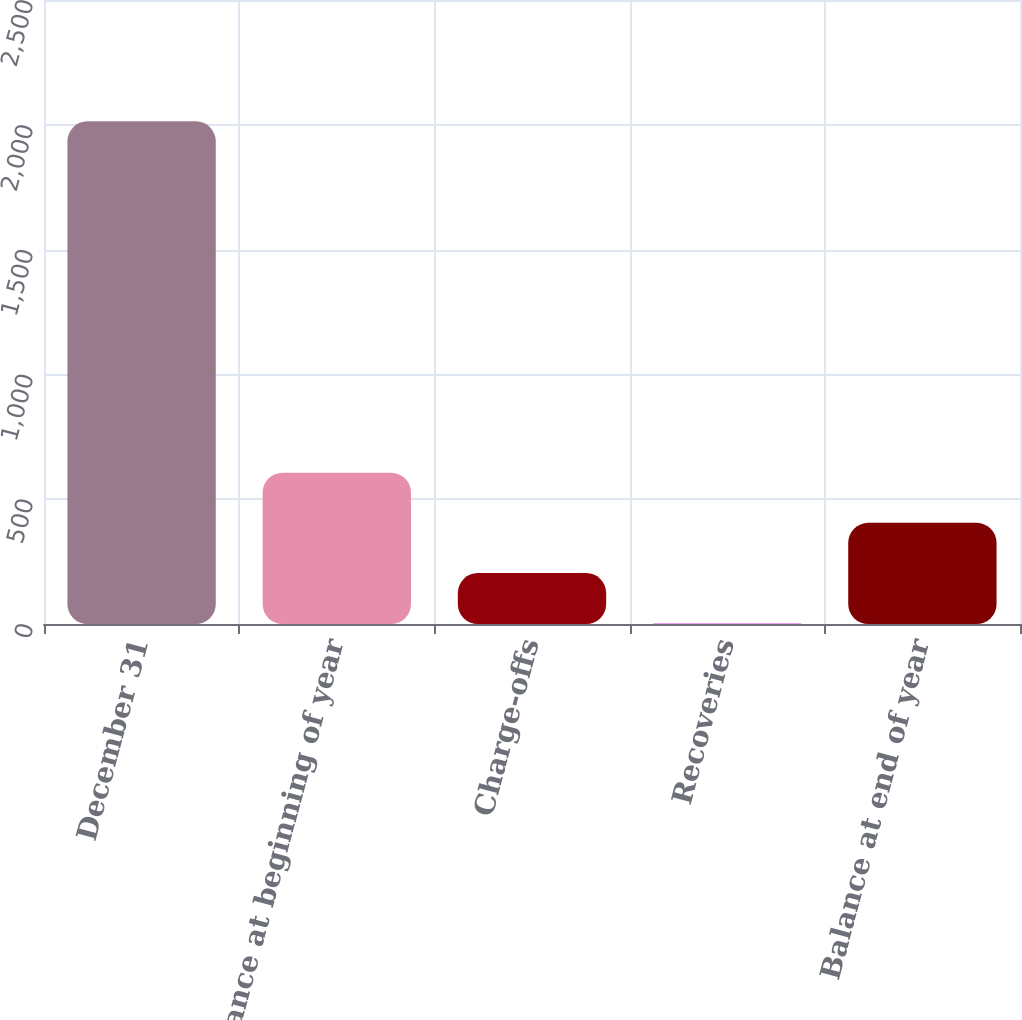<chart> <loc_0><loc_0><loc_500><loc_500><bar_chart><fcel>December 31<fcel>Balance at beginning of year<fcel>Charge-offs<fcel>Recoveries<fcel>Balance at end of year<nl><fcel>2014<fcel>606.3<fcel>204.1<fcel>3<fcel>405.2<nl></chart> 